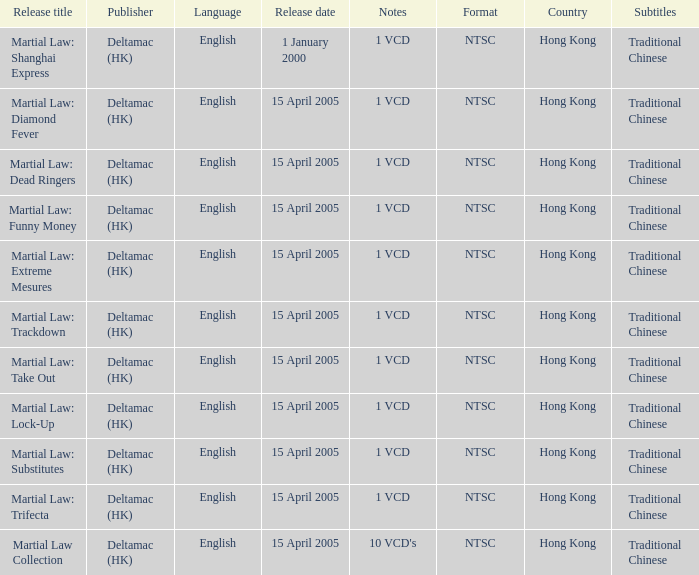Who was the publisher of Martial Law: Dead Ringers? Deltamac (HK). 